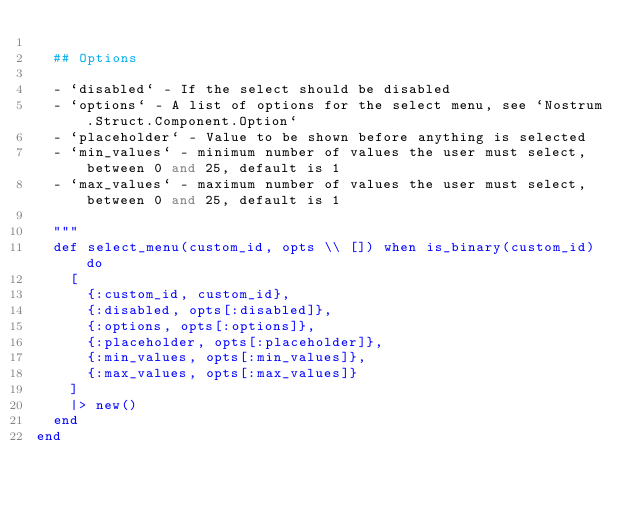<code> <loc_0><loc_0><loc_500><loc_500><_Elixir_>
  ## Options

  - `disabled` - If the select should be disabled
  - `options` - A list of options for the select menu, see `Nostrum.Struct.Component.Option`
  - `placeholder` - Value to be shown before anything is selected
  - `min_values` - minimum number of values the user must select, between 0 and 25, default is 1
  - `max_values` - maximum number of values the user must select, between 0 and 25, default is 1

  """
  def select_menu(custom_id, opts \\ []) when is_binary(custom_id) do
    [
      {:custom_id, custom_id},
      {:disabled, opts[:disabled]},
      {:options, opts[:options]},
      {:placeholder, opts[:placeholder]},
      {:min_values, opts[:min_values]},
      {:max_values, opts[:max_values]}
    ]
    |> new()
  end
end
</code> 